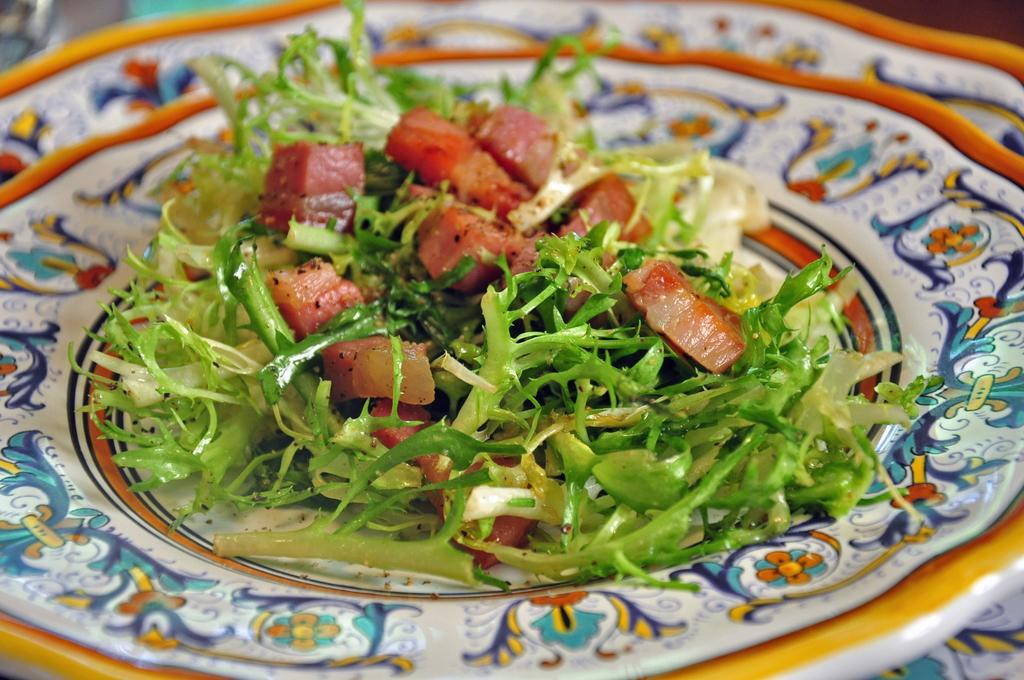What is on the plate that is visible in the image? There is food on a floral plate in the image. Can you describe another plate visible in the image? There is another plate visible at the bottom of the image. What type of debt is being discussed in the image? There is no mention or indication of any debt in the image. How many clovers are present on the plate in the image? There are no clovers visible on the plate in the image. 